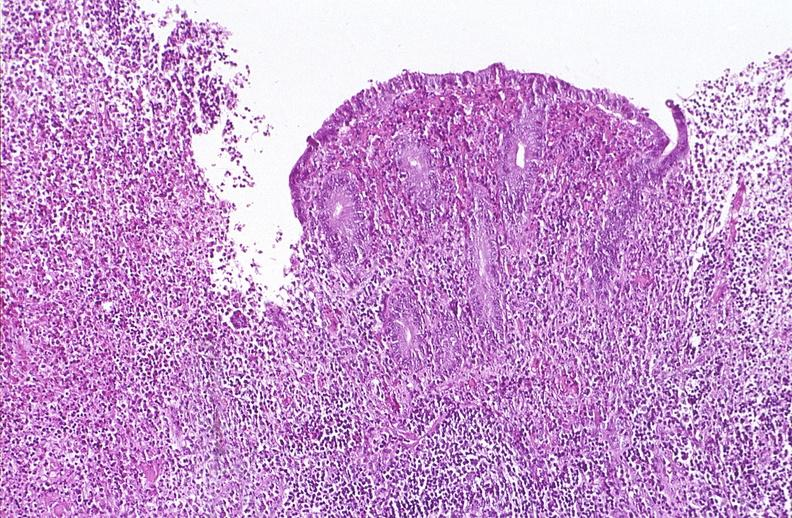does edema show appendix, acute appendicitis with ulceration of mucosa?
Answer the question using a single word or phrase. No 